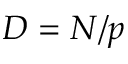Convert formula to latex. <formula><loc_0><loc_0><loc_500><loc_500>D = N / p</formula> 